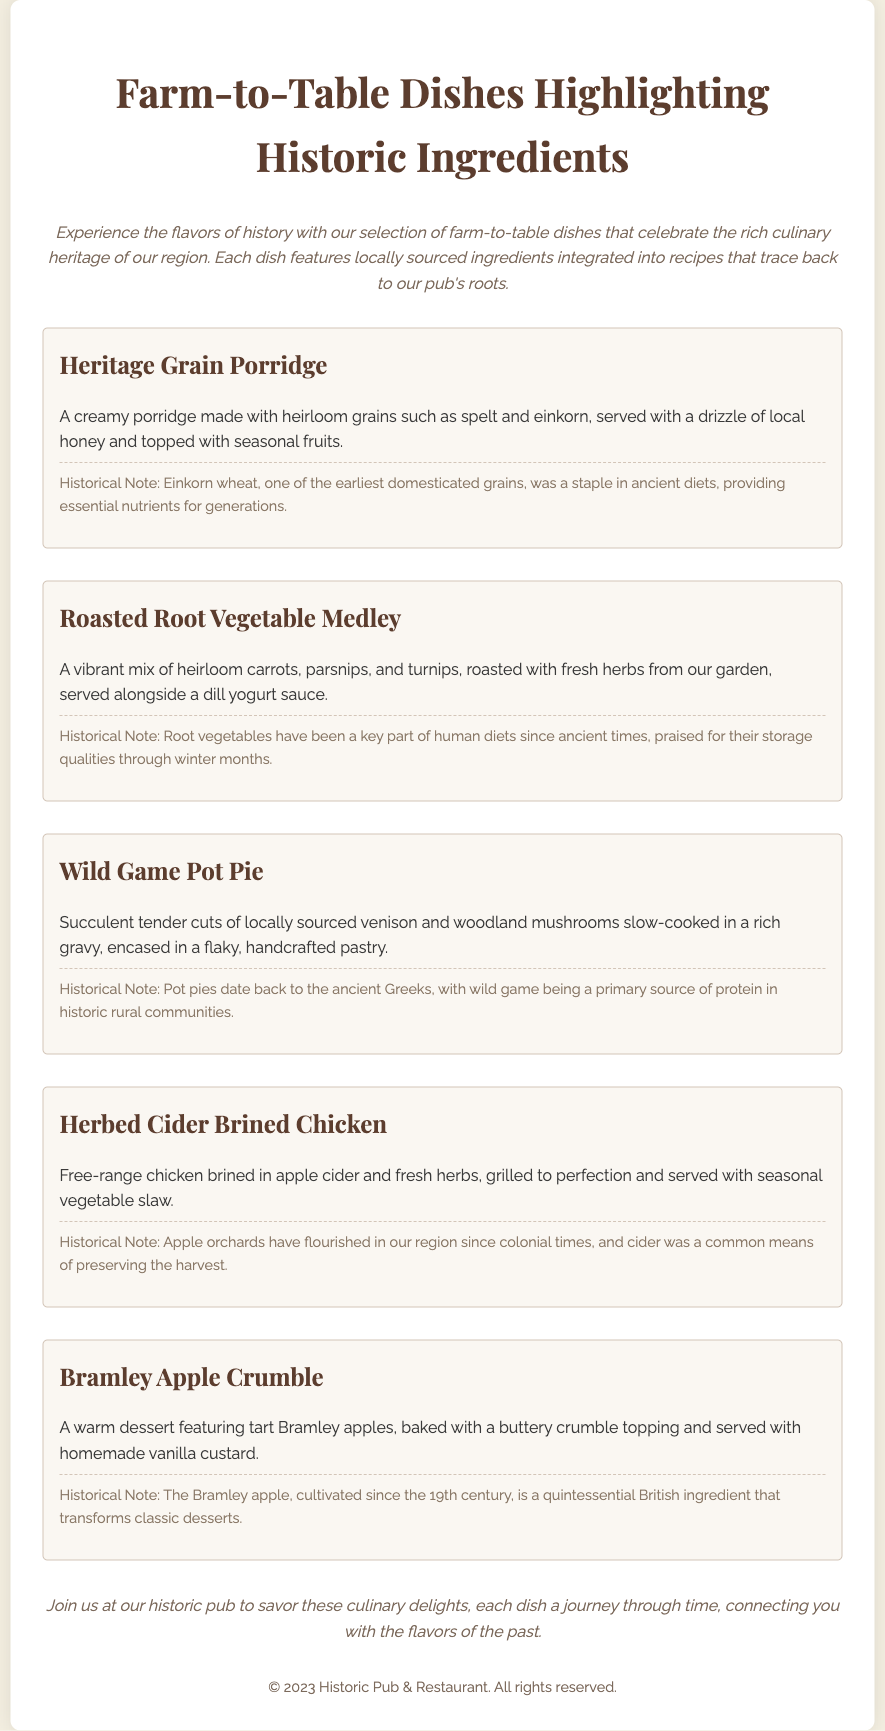What are the main ingredients in the Heritage Grain Porridge? The dish is made with heirloom grains such as spelt and einkorn, served with local honey and seasonal fruits.
Answer: spelt and einkorn What historical ingredient is noted in the Wild Game Pot Pie? The note mentions wild game as a primary source of protein in historic rural communities.
Answer: wild game Which dish features Bramley apples? The menu lists a dessert that includes Bramley apples, specifically the one with a buttery crumble topping.
Answer: Bramley Apple Crumble What type of chicken is used in the Herbed Cider Brined Chicken dish? The description states that the chicken is free-range and brined in apple cider and fresh herbs.
Answer: free-range chicken How many farm-to-table dishes are listed in the menu? There are five distinct dishes highlighted in the document, each with a description and historical note.
Answer: five What is the primary cooking method used for the Roasted Root Vegetable Medley? The dish features a vibrant mix of vegetables that are roasted with fresh herbs.
Answer: roasted What is the purpose of the historical notes included with each dish? The notes provide context about the ingredients' significance and their historical usage in diets.
Answer: context What is the concluding statement inviting customers to do? The conclusion encourages visitors to join the pub and savor the culinary delights mentioned earlier.
Answer: savor these culinary delights 